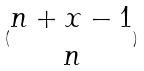Convert formula to latex. <formula><loc_0><loc_0><loc_500><loc_500>( \begin{matrix} n + x - 1 \\ n \end{matrix} )</formula> 